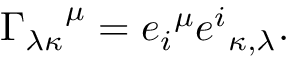Convert formula to latex. <formula><loc_0><loc_0><loc_500><loc_500>{ \Gamma _ { \lambda \kappa } } ^ { \mu } = { e _ { i } } ^ { \mu } { e ^ { i } } _ { \kappa , \lambda } .</formula> 